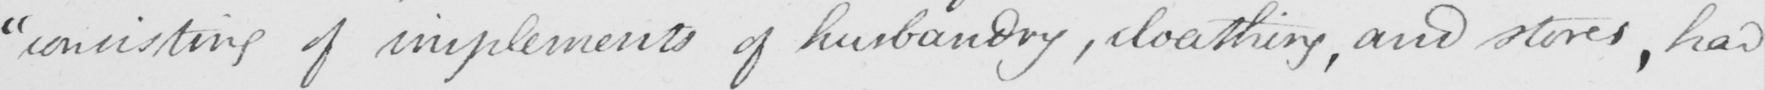Can you tell me what this handwritten text says? " consisting of implements of husbandry , cloathing , and stores , had 